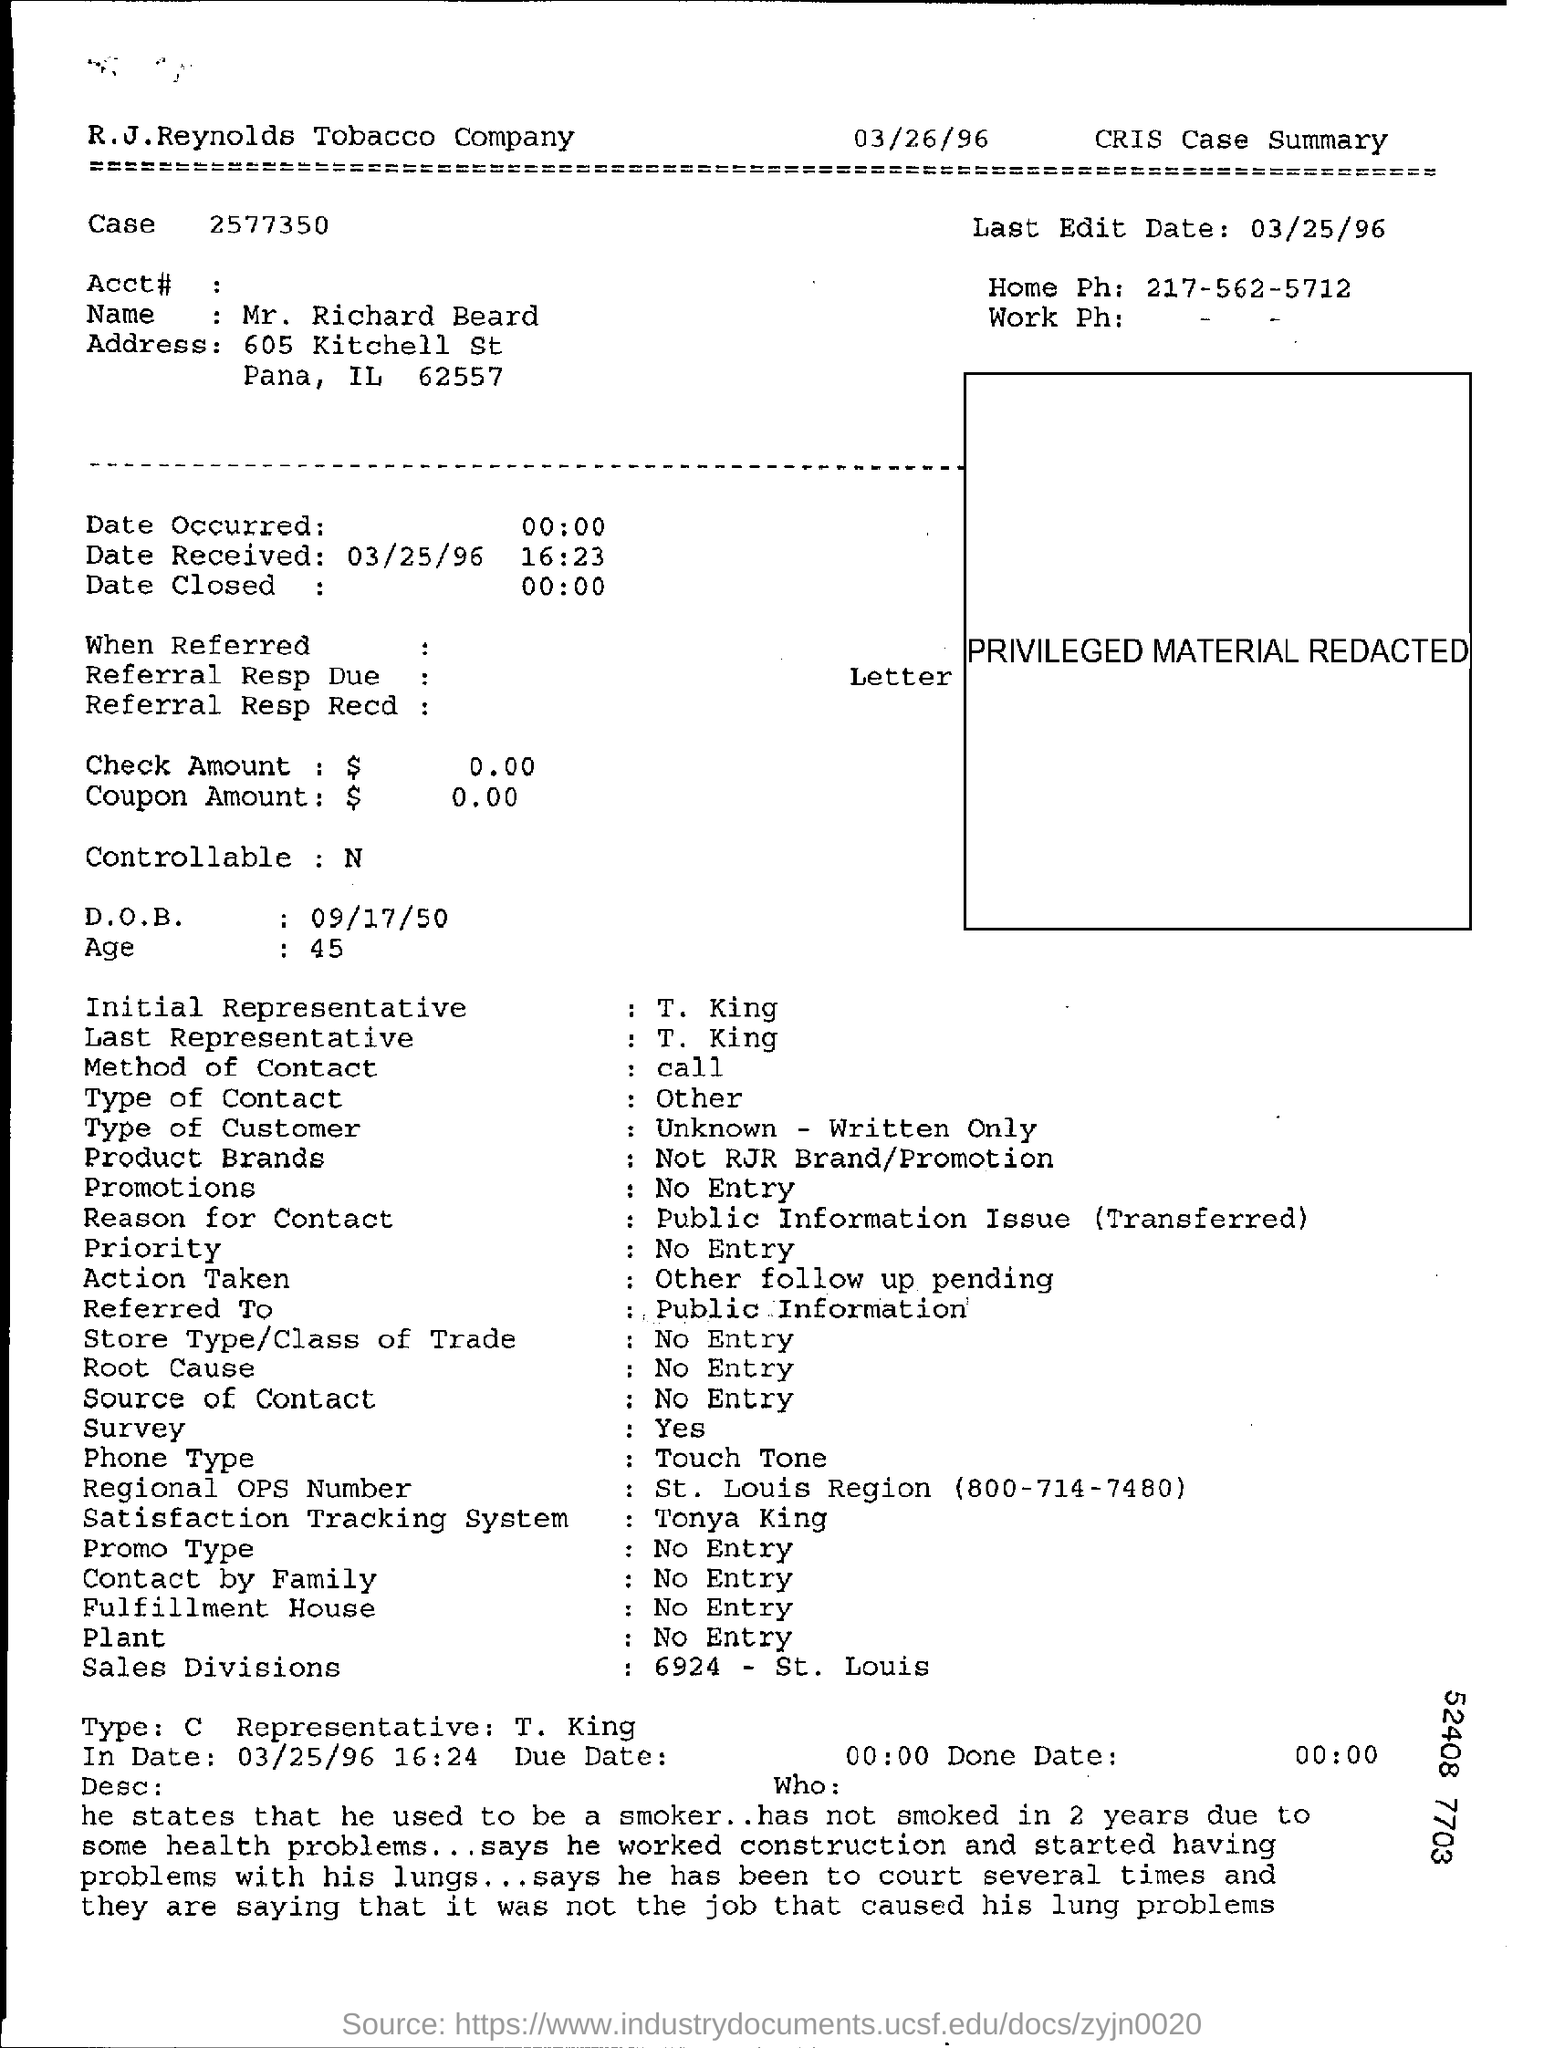Give some essential details in this illustration. The person has not smoked for two years due to health problems. The R.J.Reynolds Tobacco Company is the name of a company. The last edited date mentioned is March 25, 1996. The document mentions that the method of contact is call. The last representative mentioned in the document is T. King. 